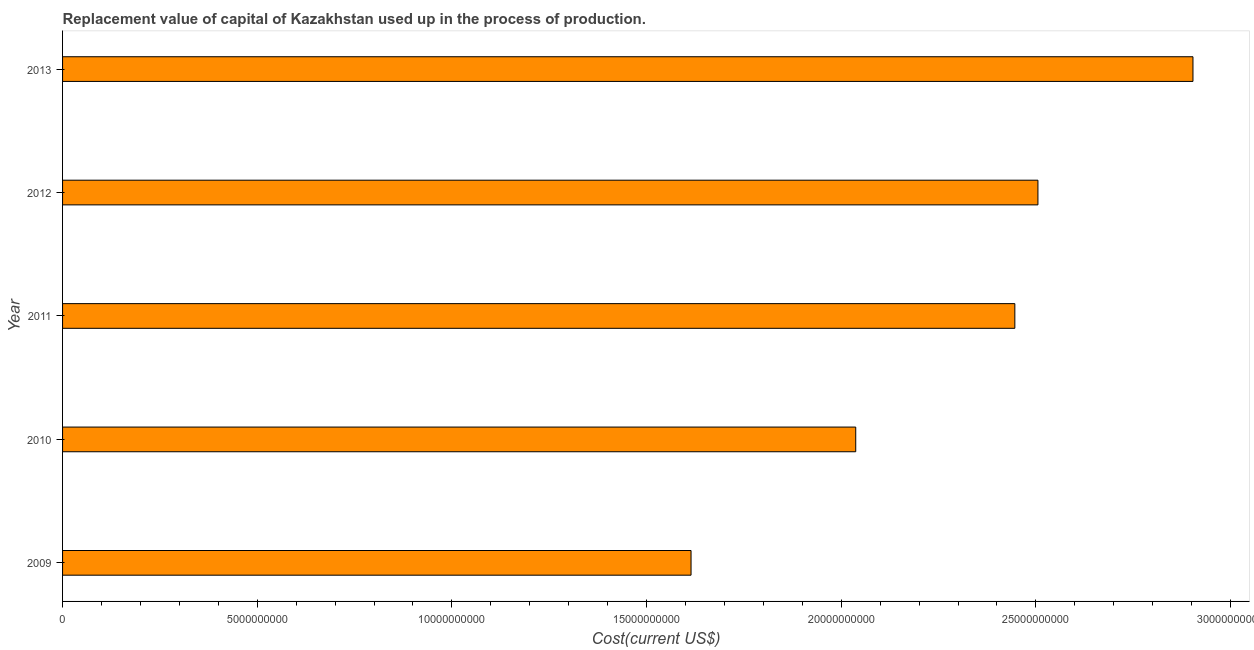Does the graph contain any zero values?
Provide a succinct answer. No. What is the title of the graph?
Your answer should be compact. Replacement value of capital of Kazakhstan used up in the process of production. What is the label or title of the X-axis?
Give a very brief answer. Cost(current US$). What is the consumption of fixed capital in 2012?
Offer a terse response. 2.51e+1. Across all years, what is the maximum consumption of fixed capital?
Your answer should be very brief. 2.90e+1. Across all years, what is the minimum consumption of fixed capital?
Your answer should be very brief. 1.61e+1. In which year was the consumption of fixed capital minimum?
Make the answer very short. 2009. What is the sum of the consumption of fixed capital?
Provide a succinct answer. 1.15e+11. What is the difference between the consumption of fixed capital in 2010 and 2013?
Provide a short and direct response. -8.66e+09. What is the average consumption of fixed capital per year?
Make the answer very short. 2.30e+1. What is the median consumption of fixed capital?
Provide a short and direct response. 2.45e+1. Do a majority of the years between 2009 and 2013 (inclusive) have consumption of fixed capital greater than 25000000000 US$?
Make the answer very short. No. What is the ratio of the consumption of fixed capital in 2010 to that in 2011?
Your response must be concise. 0.83. What is the difference between the highest and the second highest consumption of fixed capital?
Ensure brevity in your answer.  3.98e+09. What is the difference between the highest and the lowest consumption of fixed capital?
Your answer should be very brief. 1.29e+1. In how many years, is the consumption of fixed capital greater than the average consumption of fixed capital taken over all years?
Offer a very short reply. 3. How many years are there in the graph?
Offer a terse response. 5. Are the values on the major ticks of X-axis written in scientific E-notation?
Make the answer very short. No. What is the Cost(current US$) in 2009?
Give a very brief answer. 1.61e+1. What is the Cost(current US$) in 2010?
Your answer should be compact. 2.04e+1. What is the Cost(current US$) of 2011?
Offer a very short reply. 2.45e+1. What is the Cost(current US$) in 2012?
Your response must be concise. 2.51e+1. What is the Cost(current US$) in 2013?
Ensure brevity in your answer.  2.90e+1. What is the difference between the Cost(current US$) in 2009 and 2010?
Ensure brevity in your answer.  -4.23e+09. What is the difference between the Cost(current US$) in 2009 and 2011?
Provide a succinct answer. -8.32e+09. What is the difference between the Cost(current US$) in 2009 and 2012?
Offer a very short reply. -8.91e+09. What is the difference between the Cost(current US$) in 2009 and 2013?
Provide a short and direct response. -1.29e+1. What is the difference between the Cost(current US$) in 2010 and 2011?
Ensure brevity in your answer.  -4.09e+09. What is the difference between the Cost(current US$) in 2010 and 2012?
Your answer should be very brief. -4.68e+09. What is the difference between the Cost(current US$) in 2010 and 2013?
Your response must be concise. -8.66e+09. What is the difference between the Cost(current US$) in 2011 and 2012?
Offer a terse response. -5.93e+08. What is the difference between the Cost(current US$) in 2011 and 2013?
Provide a short and direct response. -4.58e+09. What is the difference between the Cost(current US$) in 2012 and 2013?
Offer a very short reply. -3.98e+09. What is the ratio of the Cost(current US$) in 2009 to that in 2010?
Offer a very short reply. 0.79. What is the ratio of the Cost(current US$) in 2009 to that in 2011?
Your answer should be very brief. 0.66. What is the ratio of the Cost(current US$) in 2009 to that in 2012?
Ensure brevity in your answer.  0.64. What is the ratio of the Cost(current US$) in 2009 to that in 2013?
Make the answer very short. 0.56. What is the ratio of the Cost(current US$) in 2010 to that in 2011?
Offer a terse response. 0.83. What is the ratio of the Cost(current US$) in 2010 to that in 2012?
Give a very brief answer. 0.81. What is the ratio of the Cost(current US$) in 2010 to that in 2013?
Your answer should be compact. 0.7. What is the ratio of the Cost(current US$) in 2011 to that in 2013?
Make the answer very short. 0.84. What is the ratio of the Cost(current US$) in 2012 to that in 2013?
Offer a very short reply. 0.86. 